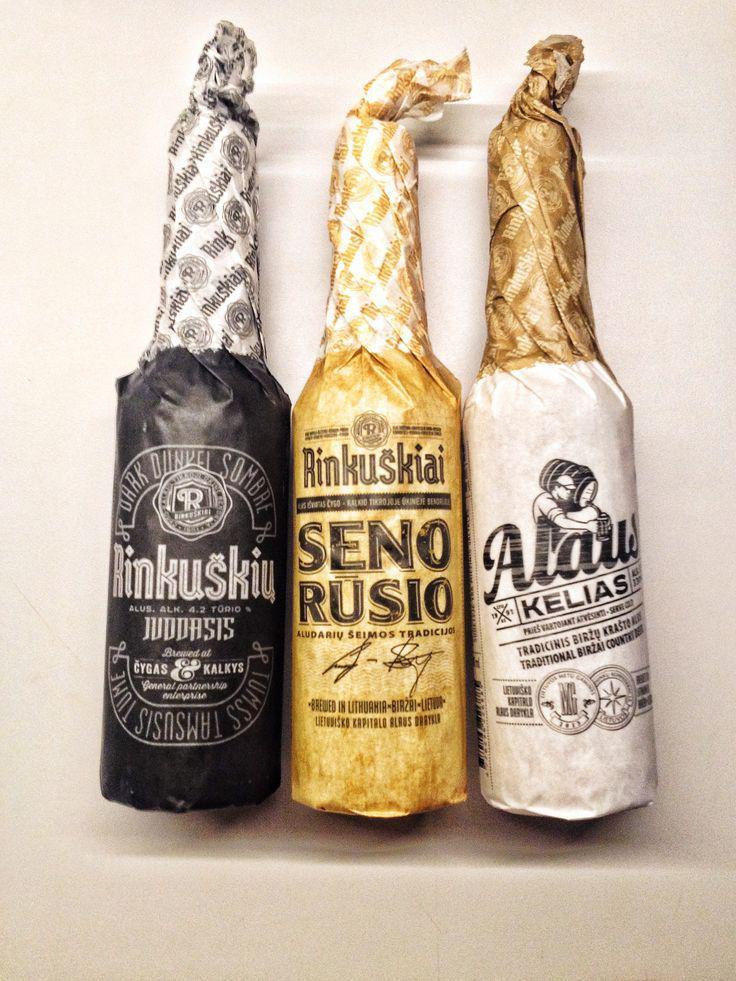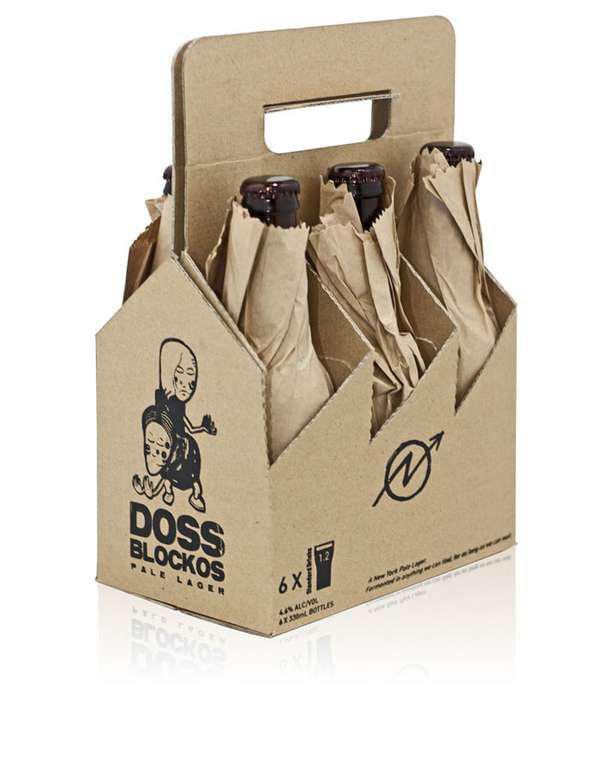The first image is the image on the left, the second image is the image on the right. Examine the images to the left and right. Is the description "There are exactly two bottles wrapped in paper." accurate? Answer yes or no. No. The first image is the image on the left, the second image is the image on the right. Given the left and right images, does the statement "Each image contains only paper-wrapped bottles, and the left image features one wide-bottomed bottled with a ring shape around the neck and its cap exposed." hold true? Answer yes or no. No. 